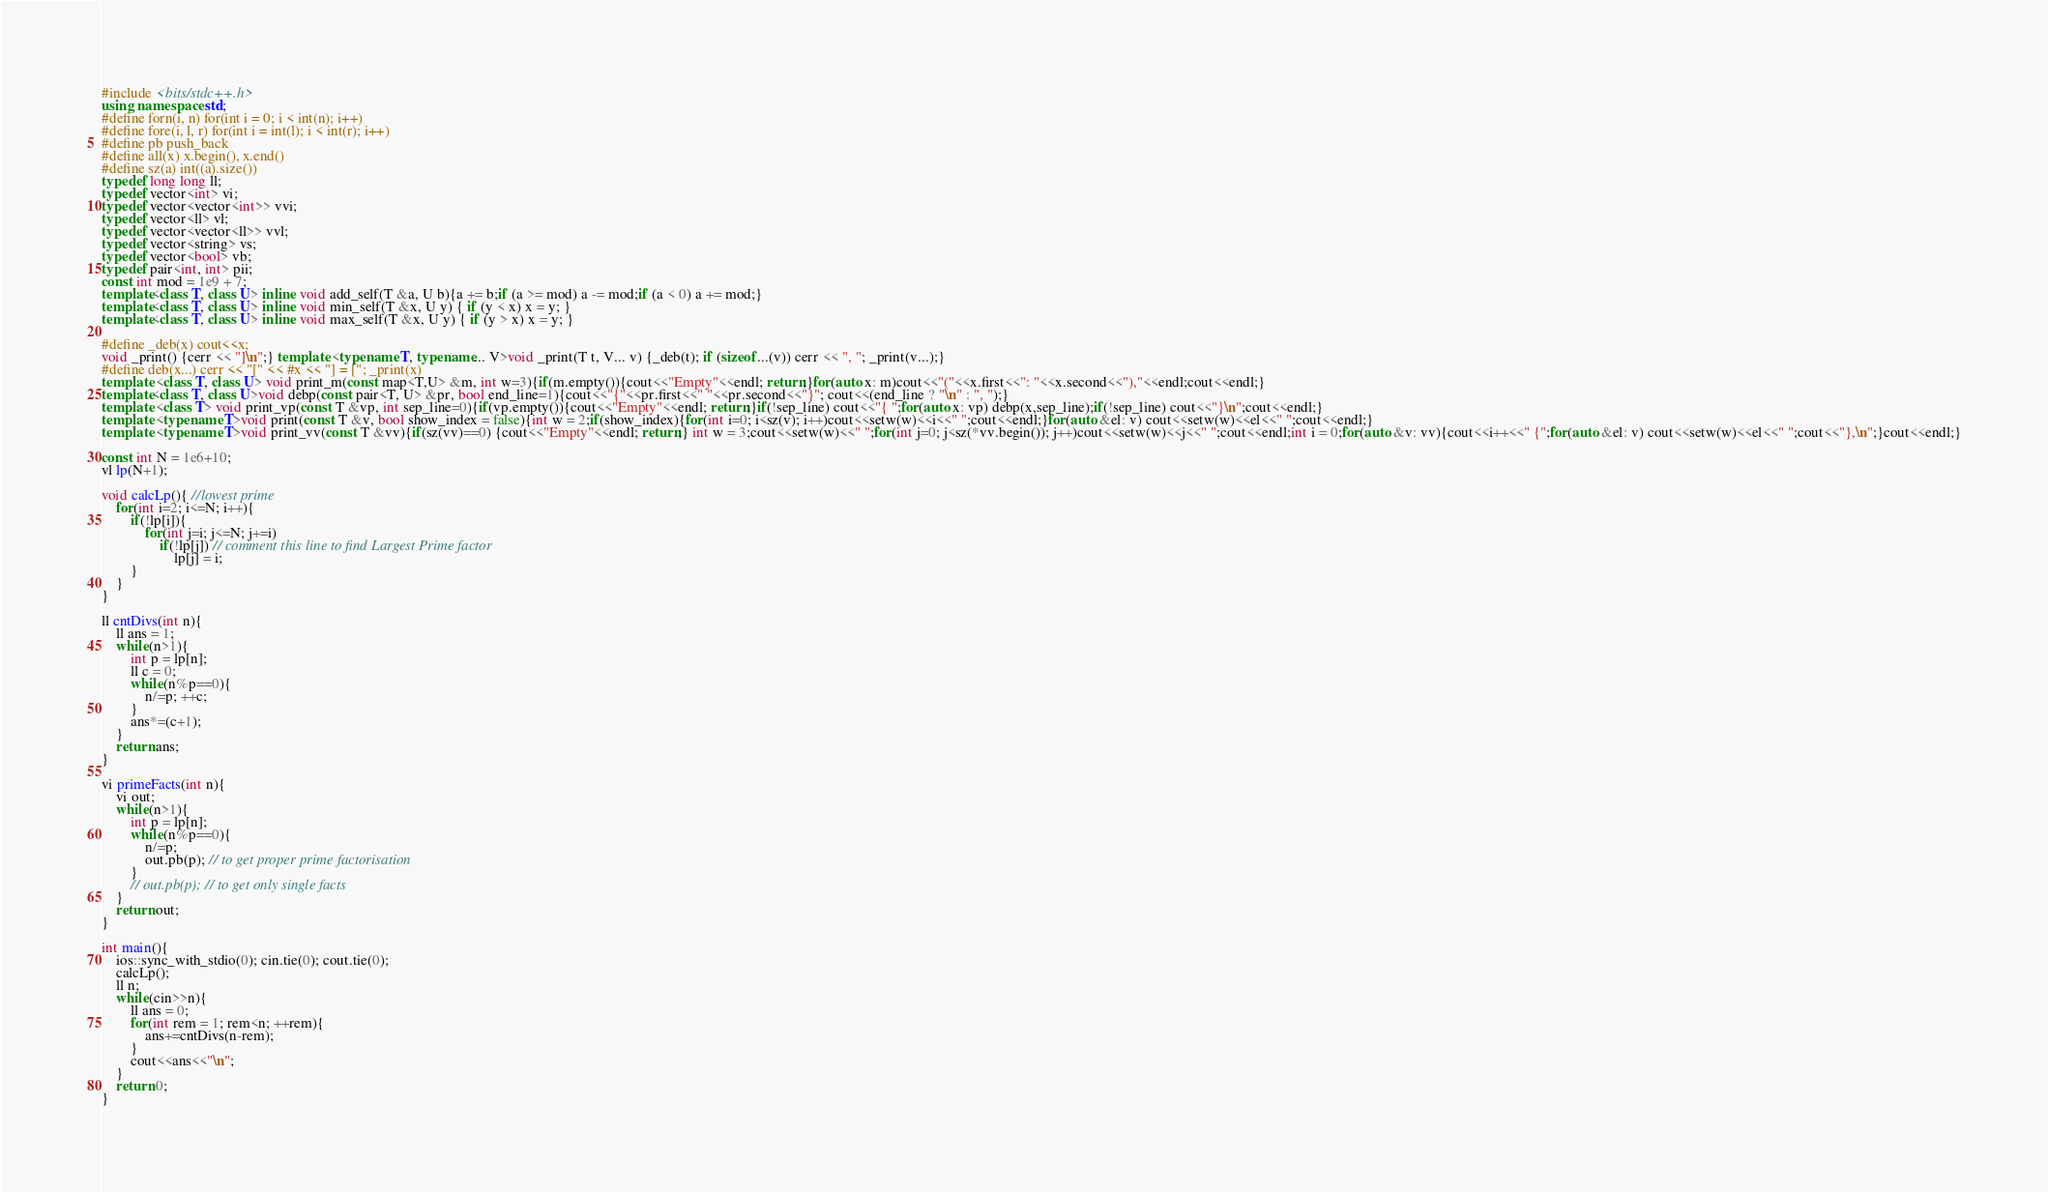Convert code to text. <code><loc_0><loc_0><loc_500><loc_500><_C++_>#include <bits/stdc++.h>
using namespace std;
#define forn(i, n) for(int i = 0; i < int(n); i++)
#define fore(i, l, r) for(int i = int(l); i < int(r); i++)
#define pb push_back
#define all(x) x.begin(), x.end()
#define sz(a) int((a).size())
typedef long long ll;
typedef vector<int> vi;
typedef vector<vector<int>> vvi;
typedef vector<ll> vl;
typedef vector<vector<ll>> vvl;
typedef vector<string> vs;
typedef vector<bool> vb;
typedef pair<int, int> pii;
const int mod = 1e9 + 7;
template<class T, class U> inline void add_self(T &a, U b){a += b;if (a >= mod) a -= mod;if (a < 0) a += mod;}
template<class T, class U> inline void min_self(T &x, U y) { if (y < x) x = y; }
template<class T, class U> inline void max_self(T &x, U y) { if (y > x) x = y; }

#define _deb(x) cout<<x;
void _print() {cerr << "]\n";} template <typename T, typename... V>void _print(T t, V... v) {_deb(t); if (sizeof...(v)) cerr << ", "; _print(v...);}
#define deb(x...) cerr << "[" << #x << "] = ["; _print(x)
template <class T, class U> void print_m(const map<T,U> &m, int w=3){if(m.empty()){cout<<"Empty"<<endl; return;}for(auto x: m)cout<<"("<<x.first<<": "<<x.second<<"),"<<endl;cout<<endl;}
template<class T, class U>void debp(const pair<T, U> &pr, bool end_line=1){cout<<"{"<<pr.first<<" "<<pr.second<<"}"; cout<<(end_line ? "\n" : ", ");}
template <class T> void print_vp(const T &vp, int sep_line=0){if(vp.empty()){cout<<"Empty"<<endl; return;}if(!sep_line) cout<<"{ ";for(auto x: vp) debp(x,sep_line);if(!sep_line) cout<<"}\n";cout<<endl;}
template <typename T>void print(const T &v, bool show_index = false){int w = 2;if(show_index){for(int i=0; i<sz(v); i++)cout<<setw(w)<<i<<" ";cout<<endl;}for(auto &el: v) cout<<setw(w)<<el<<" ";cout<<endl;}
template <typename T>void print_vv(const T &vv){if(sz(vv)==0) {cout<<"Empty"<<endl; return;} int w = 3;cout<<setw(w)<<" ";for(int j=0; j<sz(*vv.begin()); j++)cout<<setw(w)<<j<<" ";cout<<endl;int i = 0;for(auto &v: vv){cout<<i++<<" {";for(auto &el: v) cout<<setw(w)<<el<<" ";cout<<"},\n";}cout<<endl;}

const int N = 1e6+10;
vl lp(N+1);

void calcLp(){ //lowest prime
    for(int i=2; i<=N; i++){
        if(!lp[i]){
            for(int j=i; j<=N; j+=i)
                if(!lp[j]) // comment this line to find Largest Prime factor
                    lp[j] = i;
        }
    }
}

ll cntDivs(int n){
    ll ans = 1;
    while(n>1){
        int p = lp[n];
        ll c = 0;
        while(n%p==0){
            n/=p; ++c;
        }
        ans*=(c+1);
    }
    return ans;
}

vi primeFacts(int n){
    vi out;
    while(n>1){
        int p = lp[n];
        while(n%p==0){
            n/=p;
            out.pb(p); // to get proper prime factorisation
        }
        // out.pb(p); // to get only single facts
    }
    return out;
}

int main(){
    ios::sync_with_stdio(0); cin.tie(0); cout.tie(0);
    calcLp();
    ll n;
    while(cin>>n){
        ll ans = 0;
        for(int rem = 1; rem<n; ++rem){
            ans+=cntDivs(n-rem);  
        }
        cout<<ans<<"\n";
    }
    return 0;
}</code> 